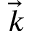<formula> <loc_0><loc_0><loc_500><loc_500>\vec { k }</formula> 